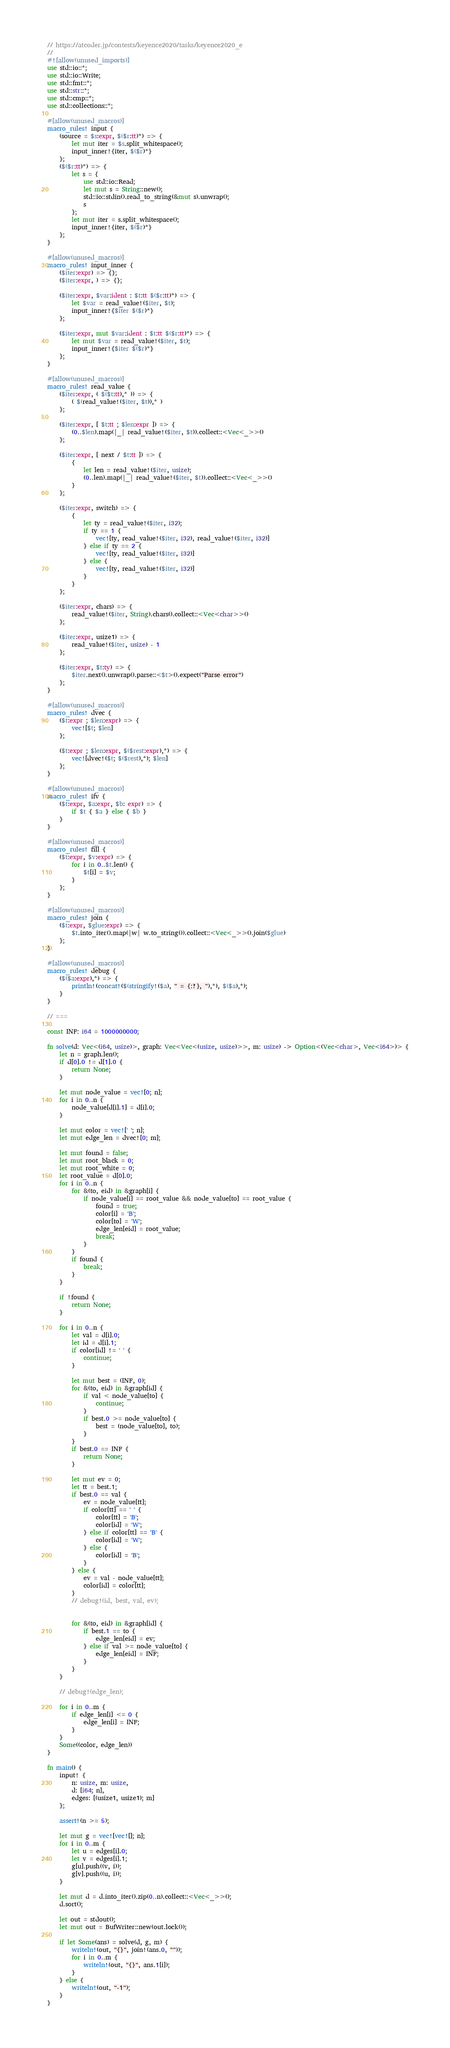Convert code to text. <code><loc_0><loc_0><loc_500><loc_500><_Rust_>// https://atcoder.jp/contests/keyence2020/tasks/keyence2020_e
//
#![allow(unused_imports)]
use std::io::*;
use std::io::Write;
use std::fmt::*;
use std::str::*;
use std::cmp::*;
use std::collections::*;

#[allow(unused_macros)]
macro_rules! input {
    (source = $s:expr, $($r:tt)*) => {
        let mut iter = $s.split_whitespace();
        input_inner!{iter, $($r)*}
    };
    ($($r:tt)*) => {
        let s = {
            use std::io::Read;
            let mut s = String::new();
            std::io::stdin().read_to_string(&mut s).unwrap();
            s
        };
        let mut iter = s.split_whitespace();
        input_inner!{iter, $($r)*}
    };
}

#[allow(unused_macros)]
macro_rules! input_inner {
    ($iter:expr) => {};
    ($iter:expr, ) => {};

    ($iter:expr, $var:ident : $t:tt $($r:tt)*) => {
        let $var = read_value!($iter, $t);
        input_inner!{$iter $($r)*}
    };

    ($iter:expr, mut $var:ident : $t:tt $($r:tt)*) => {
        let mut $var = read_value!($iter, $t);
        input_inner!{$iter $($r)*}
    };
}

#[allow(unused_macros)]
macro_rules! read_value {
    ($iter:expr, ( $($t:tt),* )) => {
        ( $(read_value!($iter, $t)),* )
    };

    ($iter:expr, [ $t:tt ; $len:expr ]) => {
        (0..$len).map(|_| read_value!($iter, $t)).collect::<Vec<_>>()
    };

    ($iter:expr, [ next / $t:tt ]) => {
        {
            let len = read_value!($iter, usize);
            (0..len).map(|_| read_value!($iter, $t)).collect::<Vec<_>>()
        }
    };

    ($iter:expr, switch) => {
        {
            let ty = read_value!($iter, i32);
            if ty == 1 {
                vec![ty, read_value!($iter, i32), read_value!($iter, i32)]
            } else if ty == 2 {
                vec![ty, read_value!($iter, i32)]
            } else {
                vec![ty, read_value!($iter, i32)]
            }
        }
    };

    ($iter:expr, chars) => {
        read_value!($iter, String).chars().collect::<Vec<char>>()
    };

    ($iter:expr, usize1) => {
        read_value!($iter, usize) - 1
    };

    ($iter:expr, $t:ty) => {
        $iter.next().unwrap().parse::<$t>().expect("Parse error")
    };
}

#[allow(unused_macros)]
macro_rules! dvec {
    ($t:expr ; $len:expr) => {
        vec![$t; $len]
    };

    ($t:expr ; $len:expr, $($rest:expr),*) => {
        vec![dvec!($t; $($rest),*); $len]
    };
}

#[allow(unused_macros)]
macro_rules! ifv {
    ($t:expr, $a:expr, $b: expr) => {
        if $t { $a } else { $b }
    }
}

#[allow(unused_macros)]
macro_rules! fill {
    ($t:expr, $v:expr) => {
        for i in 0..$t.len() {
            $t[i] = $v;
        }
    };
}

#[allow(unused_macros)]
macro_rules! join {
    ($t:expr, $glue:expr) => {
        $t.into_iter().map(|w| w.to_string()).collect::<Vec<_>>().join($glue)
    };
}

#[allow(unused_macros)]
macro_rules! debug {
    ($($a:expr),*) => {
        println!(concat!($(stringify!($a), " = {:?}, "),*), $($a),*);
    }
}

// ===

const INF: i64 = 1000000000;

fn solve(d: Vec<(i64, usize)>, graph: Vec<Vec<(usize, usize)>>, m: usize) -> Option<(Vec<char>, Vec<i64>)> {
    let n = graph.len();
    if d[0].0 != d[1].0 {
        return None;
    }

    let mut node_value = vec![0; n];
    for i in 0..n {
        node_value[d[i].1] = d[i].0;
    }

    let mut color = vec![' '; n];
    let mut edge_len = dvec![0; m];

    let mut found = false;
    let mut root_black = 0;
    let mut root_white = 0;
    let root_value = d[0].0;
    for i in 0..n {
        for &(to, eid) in &graph[i] {
            if node_value[i] == root_value && node_value[to] == root_value {
                found = true;
                color[i] = 'B';
                color[to] = 'W';
                edge_len[eid] = root_value;
                break;
            }
        }
        if found {
            break;
        }
    }

    if !found {
        return None;
    }

    for i in 0..n {
        let val = d[i].0;
        let id = d[i].1;
        if color[id] != ' ' {
            continue;
        }

        let mut best = (INF, 0);
        for &(to, eid) in &graph[id] {
            if val < node_value[to] {
                continue;
            }
            if best.0 >= node_value[to] {
                best = (node_value[to], to);
            }
        }
        if best.0 == INF {
            return None;
        }

        let mut ev = 0;
        let tt = best.1;
        if best.0 == val {
            ev = node_value[tt];
            if color[tt] == ' ' {
                color[tt] = 'B';
                color[id] = 'W';
            } else if color[tt] == 'B' {
                color[id] = 'W';
            } else {
                color[id] = 'B';
            }
        } else {
            ev = val - node_value[tt];
            color[id] = color[tt];
        }
        // debug!(id, best, val, ev);


        for &(to, eid) in &graph[id] {
            if best.1 == to {
                edge_len[eid] = ev;
            } else if val >= node_value[to] {
                edge_len[eid] = INF;
            }
        }
    }

    // debug!(edge_len);

    for i in 0..m {
        if edge_len[i] <= 0 {
            edge_len[i] = INF;
        }
    }
    Some((color, edge_len))
}

fn main() {
    input! {
        n: usize, m: usize,
        d: [i64; n],
        edges: [(usize1, usize1); m]
    };

    assert!(n >= 5);

    let mut g = vec![vec![]; n];
    for i in 0..m {
        let u = edges[i].0;
        let v = edges[i].1;
        g[u].push((v, i));
        g[v].push((u, i));
    }

    let mut d = d.into_iter().zip(0..n).collect::<Vec<_>>();
    d.sort();

    let out = stdout();
    let mut out = BufWriter::new(out.lock());

    if let Some(ans) = solve(d, g, m) {
        writeln!(out, "{}", join!(ans.0, ""));
        for i in 0..m {
            writeln!(out, "{}", ans.1[i]);
        }
    } else {
        writeln!(out, "-1");
    }
}
</code> 